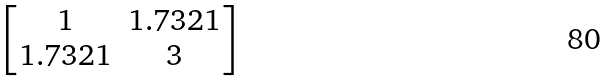<formula> <loc_0><loc_0><loc_500><loc_500>\begin{bmatrix} 1 & 1 . 7 3 2 1 \\ 1 . 7 3 2 1 & 3 \end{bmatrix}</formula> 